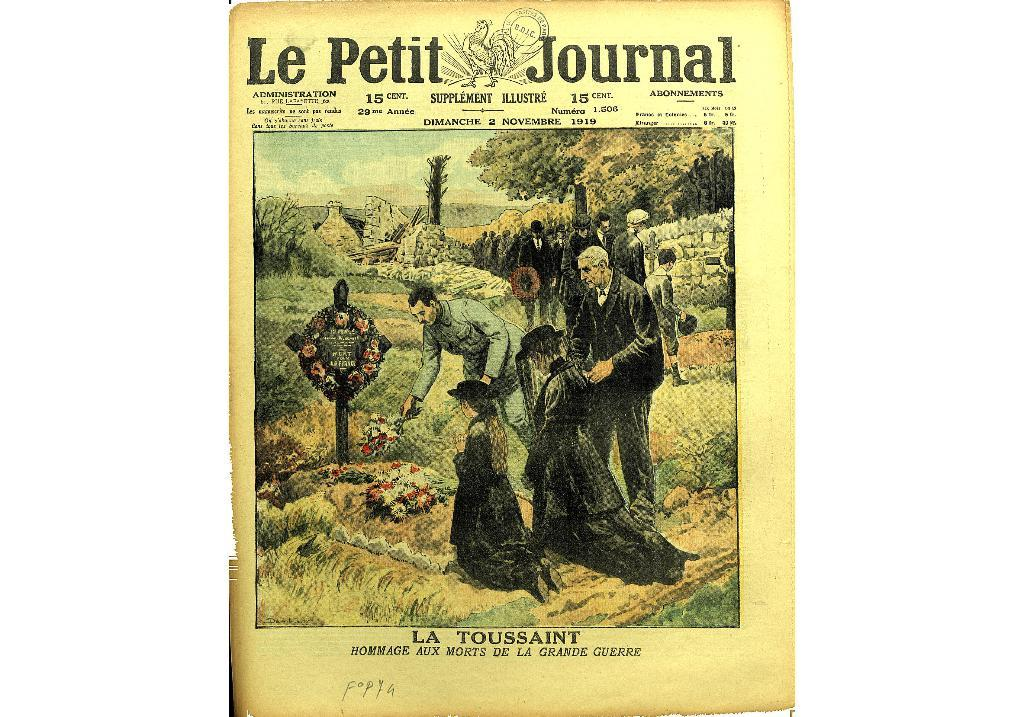<image>
Provide a brief description of the given image. The cover of "Le Petit Journal" with a drawing of some people putting flowers on a grave. 